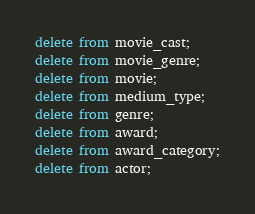Convert code to text. <code><loc_0><loc_0><loc_500><loc_500><_SQL_>delete from movie_cast;
delete from movie_genre;
delete from movie;
delete from medium_type;
delete from genre;
delete from award; 
delete from award_category;
delete from actor;</code> 